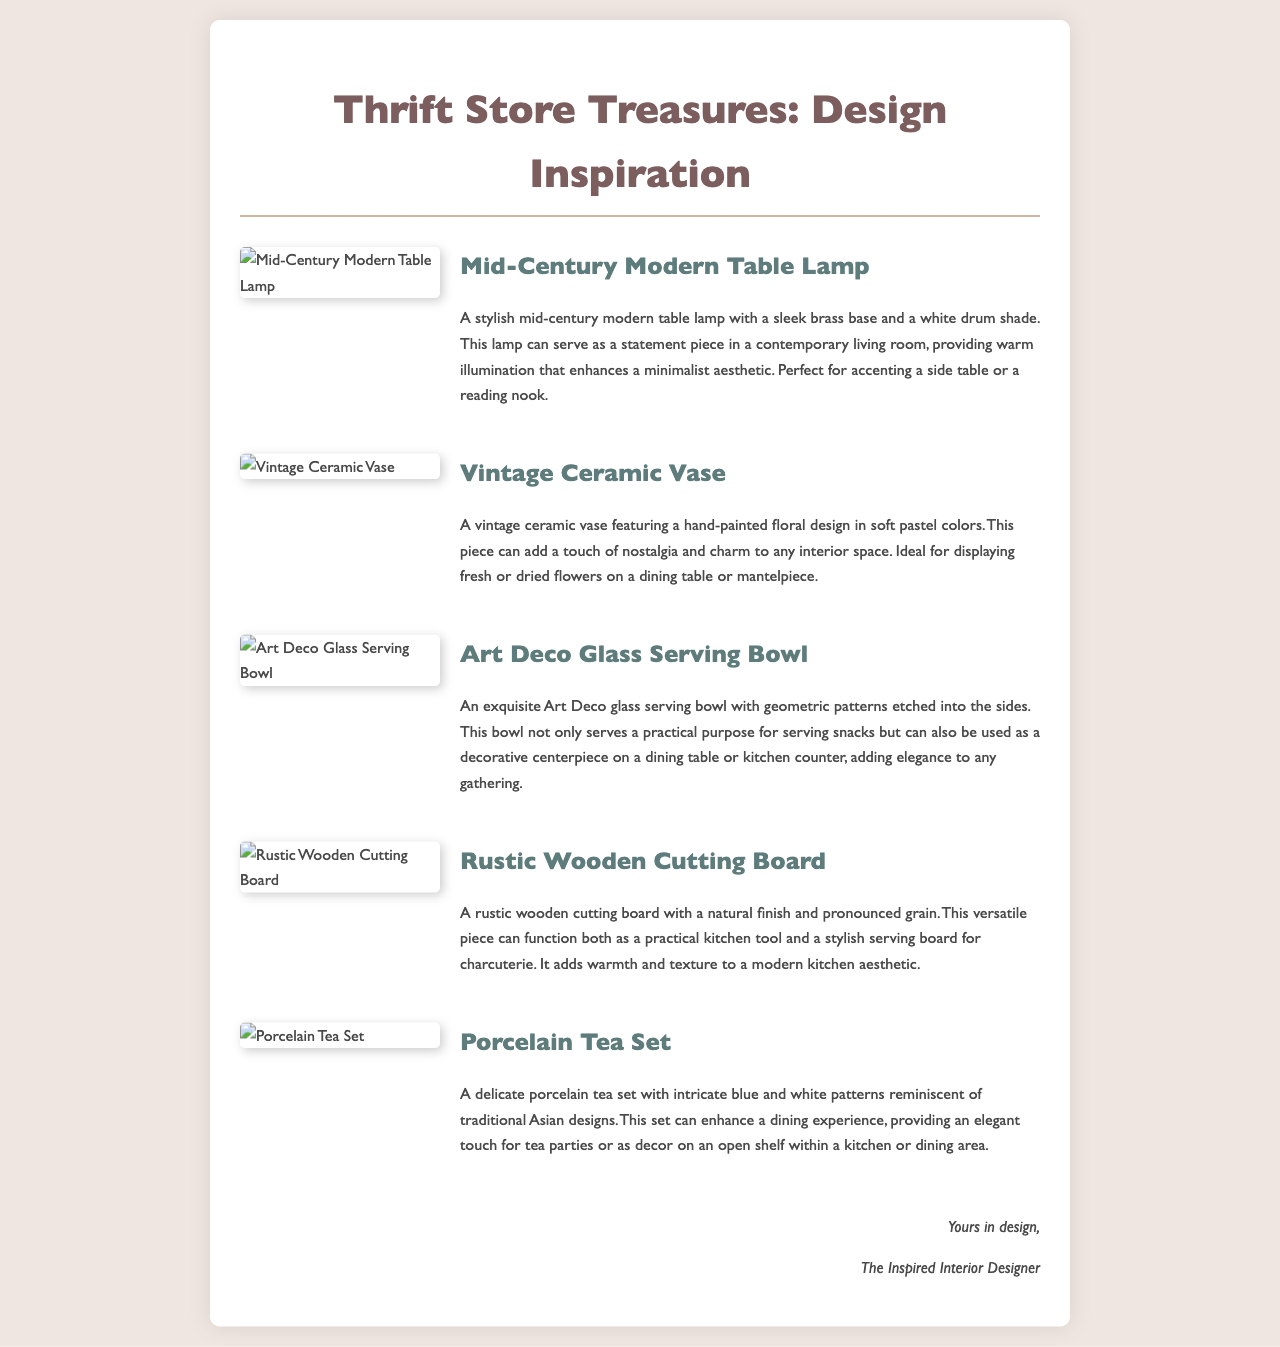What is the title of the document? The title of the document is specified in the head section as "Thrift Store Finds for Interior Design Inspiration."
Answer: Thrift Store Finds for Interior Design Inspiration How many items are listed in the document? The document features five different thrift store finds listed.
Answer: Five What is the design style of the first item? The first item, a table lamp, is categorized as mid-century modern as described in the paragraph.
Answer: Mid-Century Modern What is the potential application of the vintage ceramic vase? The vintage ceramic vase can be used for displaying fresh or dried flowers, as noted in the description.
Answer: Displaying flowers What type of serving bowl is described in the document? The bowl mentioned is classified as an Art Deco glass serving bowl based on its distinct design features.
Answer: Art Deco glass serving bowl What color scheme is featured on the porcelain tea set? The porcelain tea set features blue and white patterns as highlighted in the item's description.
Answer: Blue and white For what purpose can the rustic wooden cutting board be used? The rustic wooden cutting board serves both as a practical kitchen tool and as a stylish serving board according to the text.
Answer: Kitchen tool and serving board What is the main material of the mid-century modern table lamp? The main material of the lamp is brass, as specified in the description.
Answer: Brass What aesthetic does the vintage ceramic vase add to a space? The vintage ceramic vase adds nostalgia and charm, as indicated in the document.
Answer: Nostalgia and charm 